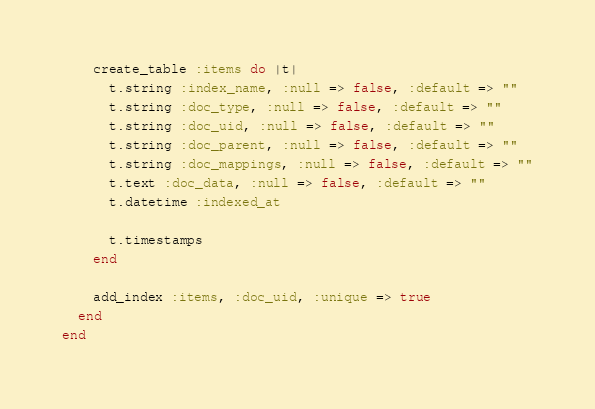Convert code to text. <code><loc_0><loc_0><loc_500><loc_500><_Ruby_>    create_table :items do |t|
      t.string :index_name, :null => false, :default => ""
      t.string :doc_type, :null => false, :default => ""
      t.string :doc_uid, :null => false, :default => ""
      t.string :doc_parent, :null => false, :default => ""
      t.string :doc_mappings, :null => false, :default => ""
      t.text :doc_data, :null => false, :default => ""
      t.datetime :indexed_at

      t.timestamps
    end

    add_index :items, :doc_uid, :unique => true
  end
end
</code> 